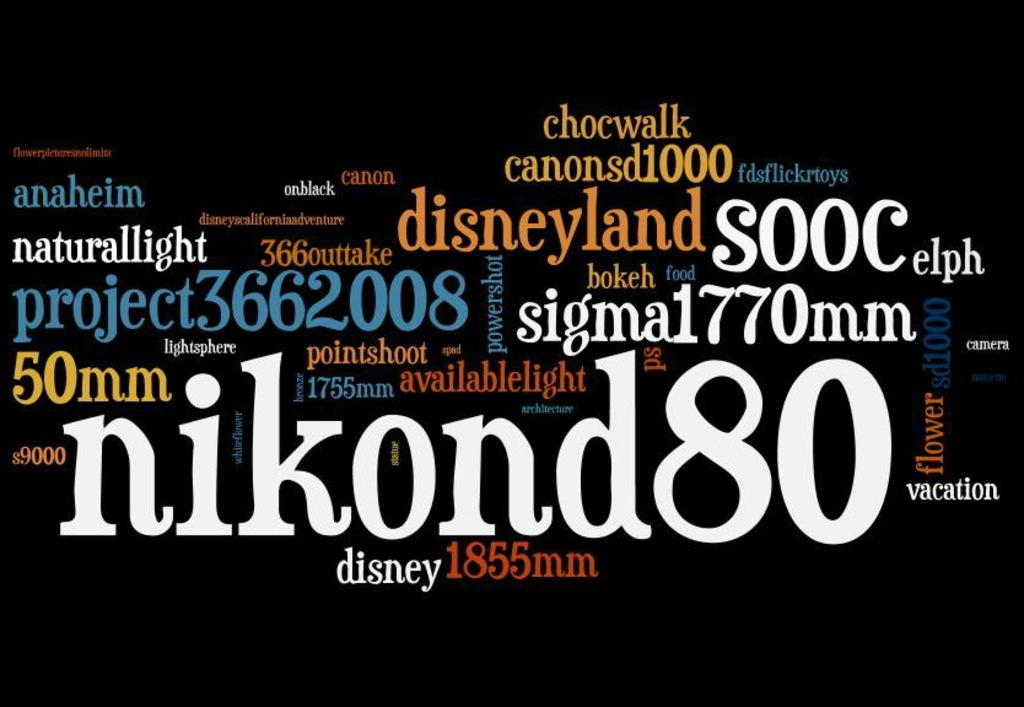<image>
Write a terse but informative summary of the picture. Several words on a black background including the word "nikond80" 